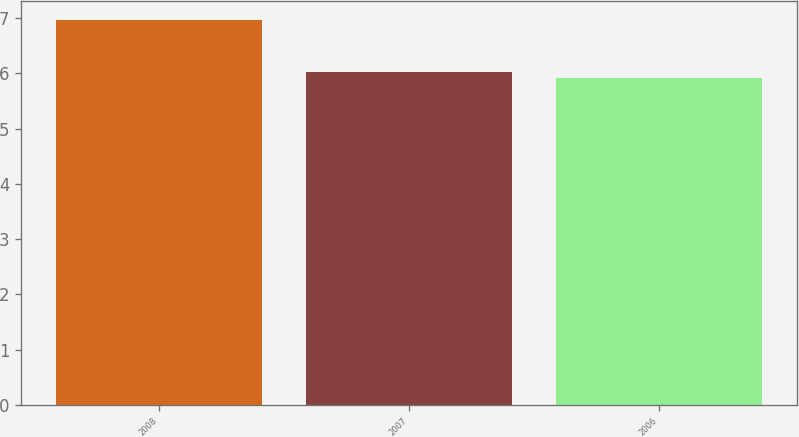Convert chart to OTSL. <chart><loc_0><loc_0><loc_500><loc_500><bar_chart><fcel>2008<fcel>2007<fcel>2006<nl><fcel>6.96<fcel>6.02<fcel>5.91<nl></chart> 